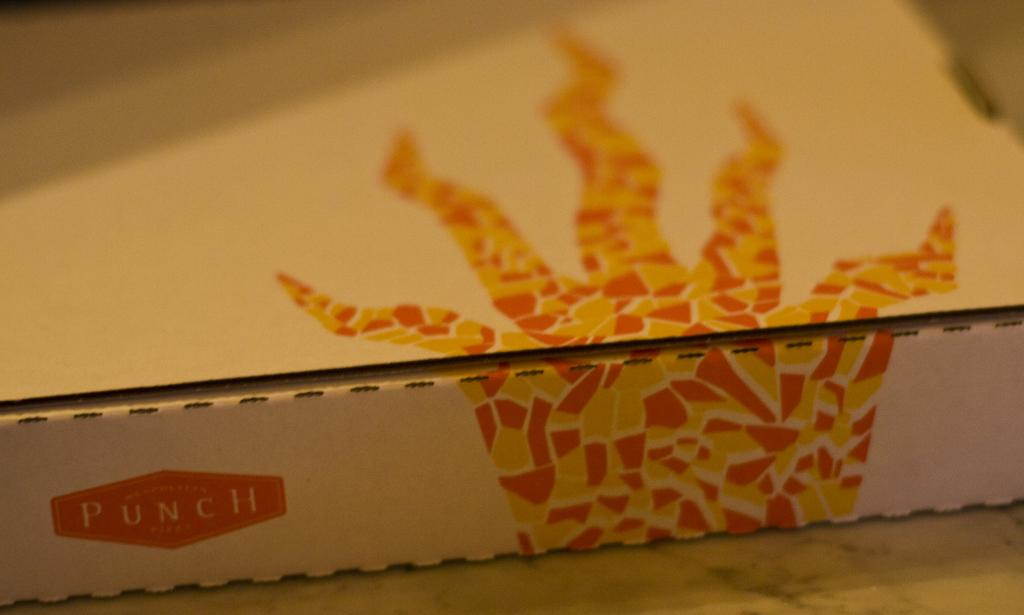<image>
Render a clear and concise summary of the photo. An orange and yellow tessellation pattern is on the box with the label PUNCH 